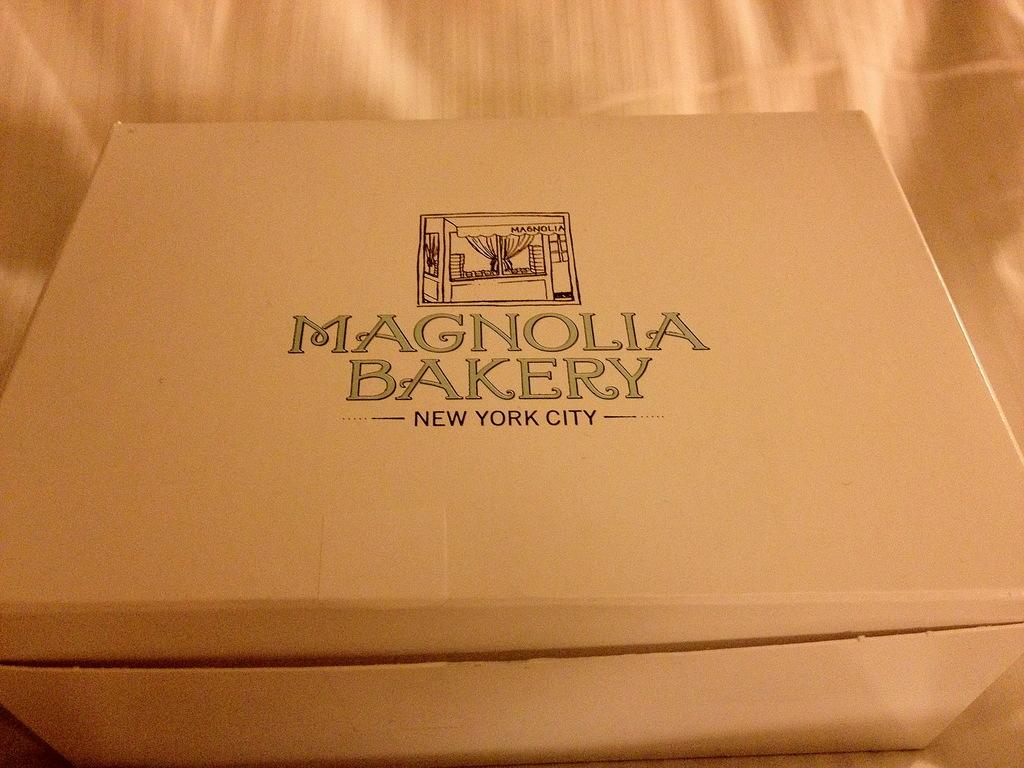<image>
Summarize the visual content of the image. A brown Magnolia Bakery New Yotk city box 